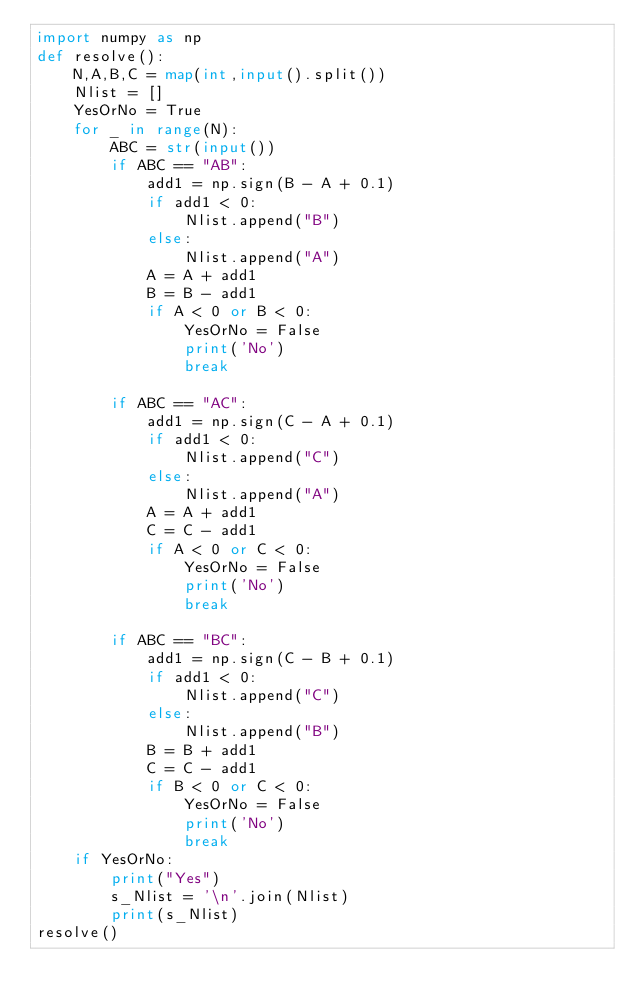Convert code to text. <code><loc_0><loc_0><loc_500><loc_500><_Python_>import numpy as np
def resolve():
    N,A,B,C = map(int,input().split())
    Nlist = []
    YesOrNo = True
    for _ in range(N):
        ABC = str(input())
        if ABC == "AB":
            add1 = np.sign(B - A + 0.1)
            if add1 < 0:
                Nlist.append("B")
            else:
                Nlist.append("A")
            A = A + add1
            B = B - add1
            if A < 0 or B < 0:
                YesOrNo = False
                print('No')
                break
        
        if ABC == "AC":
            add1 = np.sign(C - A + 0.1)
            if add1 < 0:
                Nlist.append("C")
            else:
                Nlist.append("A")
            A = A + add1
            C = C - add1
            if A < 0 or C < 0:
                YesOrNo = False
                print('No')
                break
        
        if ABC == "BC":
            add1 = np.sign(C - B + 0.1)
            if add1 < 0:
                Nlist.append("C")
            else:
                Nlist.append("B")
            B = B + add1
            C = C - add1
            if B < 0 or C < 0:
                YesOrNo = False
                print('No')
                break
    if YesOrNo:
        print("Yes")
        s_Nlist = '\n'.join(Nlist)
        print(s_Nlist)
resolve()</code> 